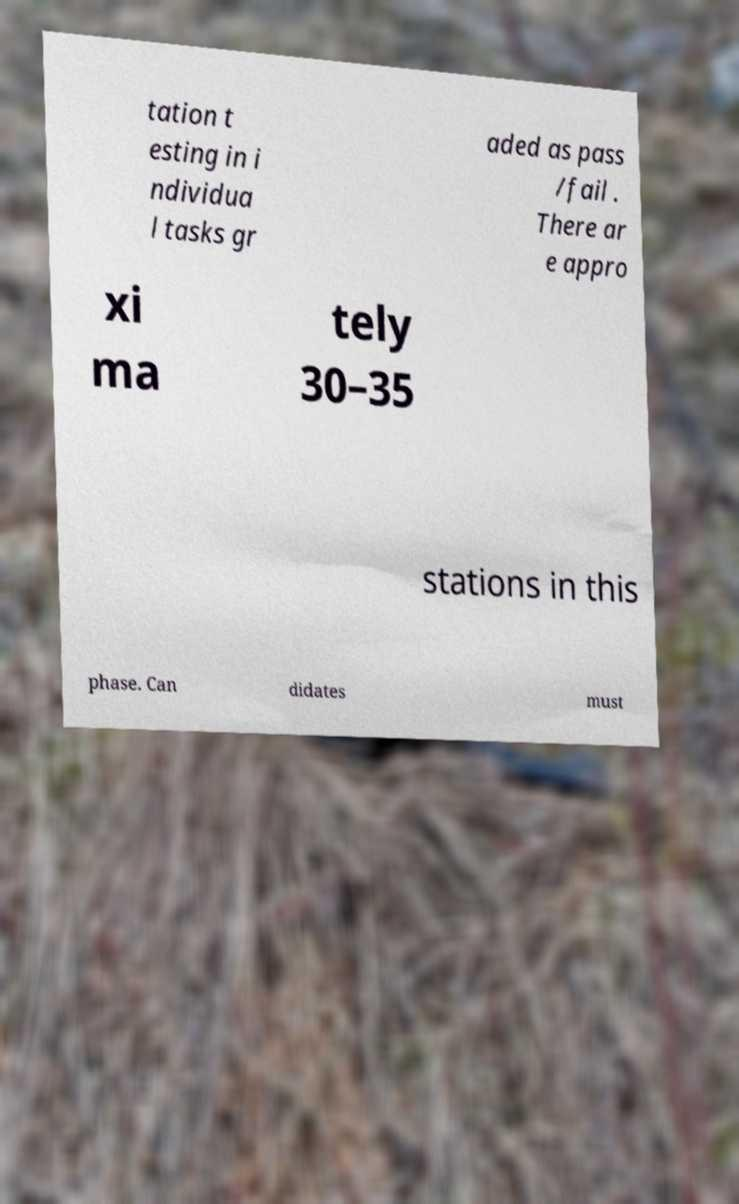Can you read and provide the text displayed in the image?This photo seems to have some interesting text. Can you extract and type it out for me? tation t esting in i ndividua l tasks gr aded as pass /fail . There ar e appro xi ma tely 30–35 stations in this phase. Can didates must 